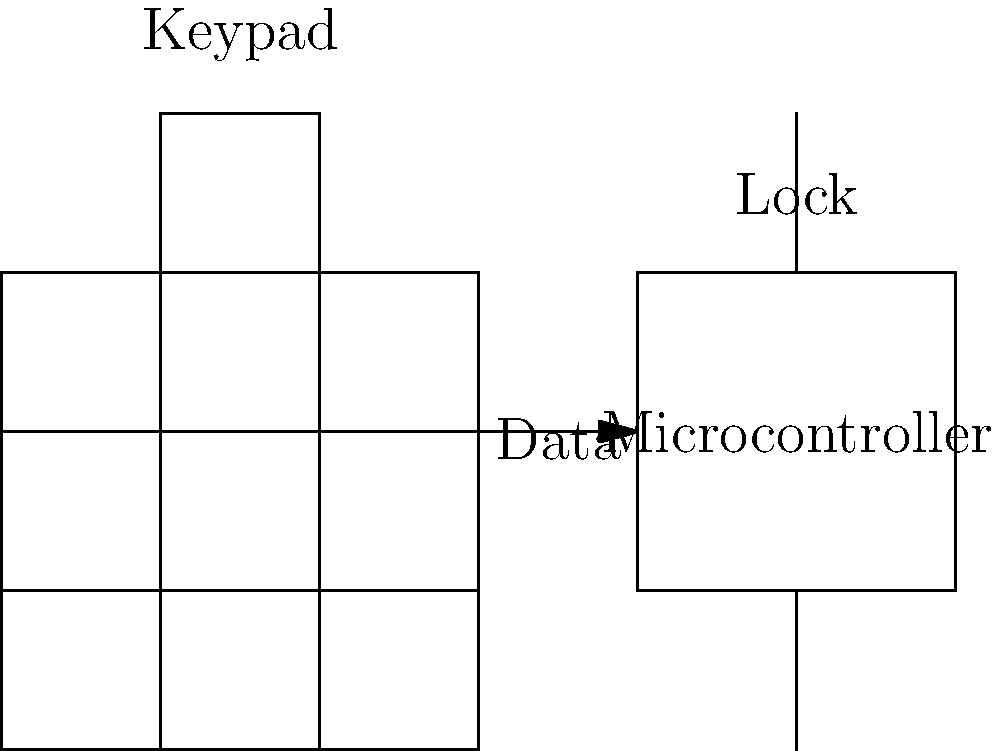Design a basic electronic lock mechanism using a 3x3 keypad and a microcontroller. The lock should open when a specific 4-digit code is entered. How would you implement a time delay feature to prevent rapid guessing attempts? To implement a time delay feature in the electronic lock mechanism:

1. Initialize variables:
   - Set `attempts = 0`
   - Set `lockout_time = 0` (in milliseconds)
   - Define `MAX_ATTEMPTS = 3`
   - Define `LOCKOUT_DURATION = 60000` (60 seconds in milliseconds)

2. In the main loop:
   a. Check if the system is in lockout:
      - If `millis() < lockout_time`, deny access and return to the start of the loop

   b. Read the keypad input

   c. If a complete 4-digit code is entered:
      - Compare it with the correct code
      - If correct:
        * Unlock the door
        * Reset `attempts = 0`
      - If incorrect:
        * Increment `attempts`
        * If `attempts >= MAX_ATTEMPTS`:
          - Set `lockout_time = millis() + LOCKOUT_DURATION`
          - Reset `attempts = 0`

3. Implement a function to read the keypad with a timeout:
   ```
   bool readKeypadWithTimeout(long timeout) {
     long start_time = millis();
     while (millis() - start_time < timeout) {
       // Read keypad
       // If valid input, return true
     }
     return false; // Timeout occurred
   }
   ```

4. Use the timeout function in the main loop to prevent hanging:
   ```
   if (readKeypadWithTimeout(5000)) {
     // Process input
   } else {
     // Clear partial input
   }
   ```

This implementation adds a 60-second lockout after three failed attempts, preventing rapid guessing while allowing legitimate users to retry after a reasonable delay.
Answer: Implement a counter for failed attempts, trigger a 60-second lockout after 3 failures, and use a timeout function for keypad reading. 